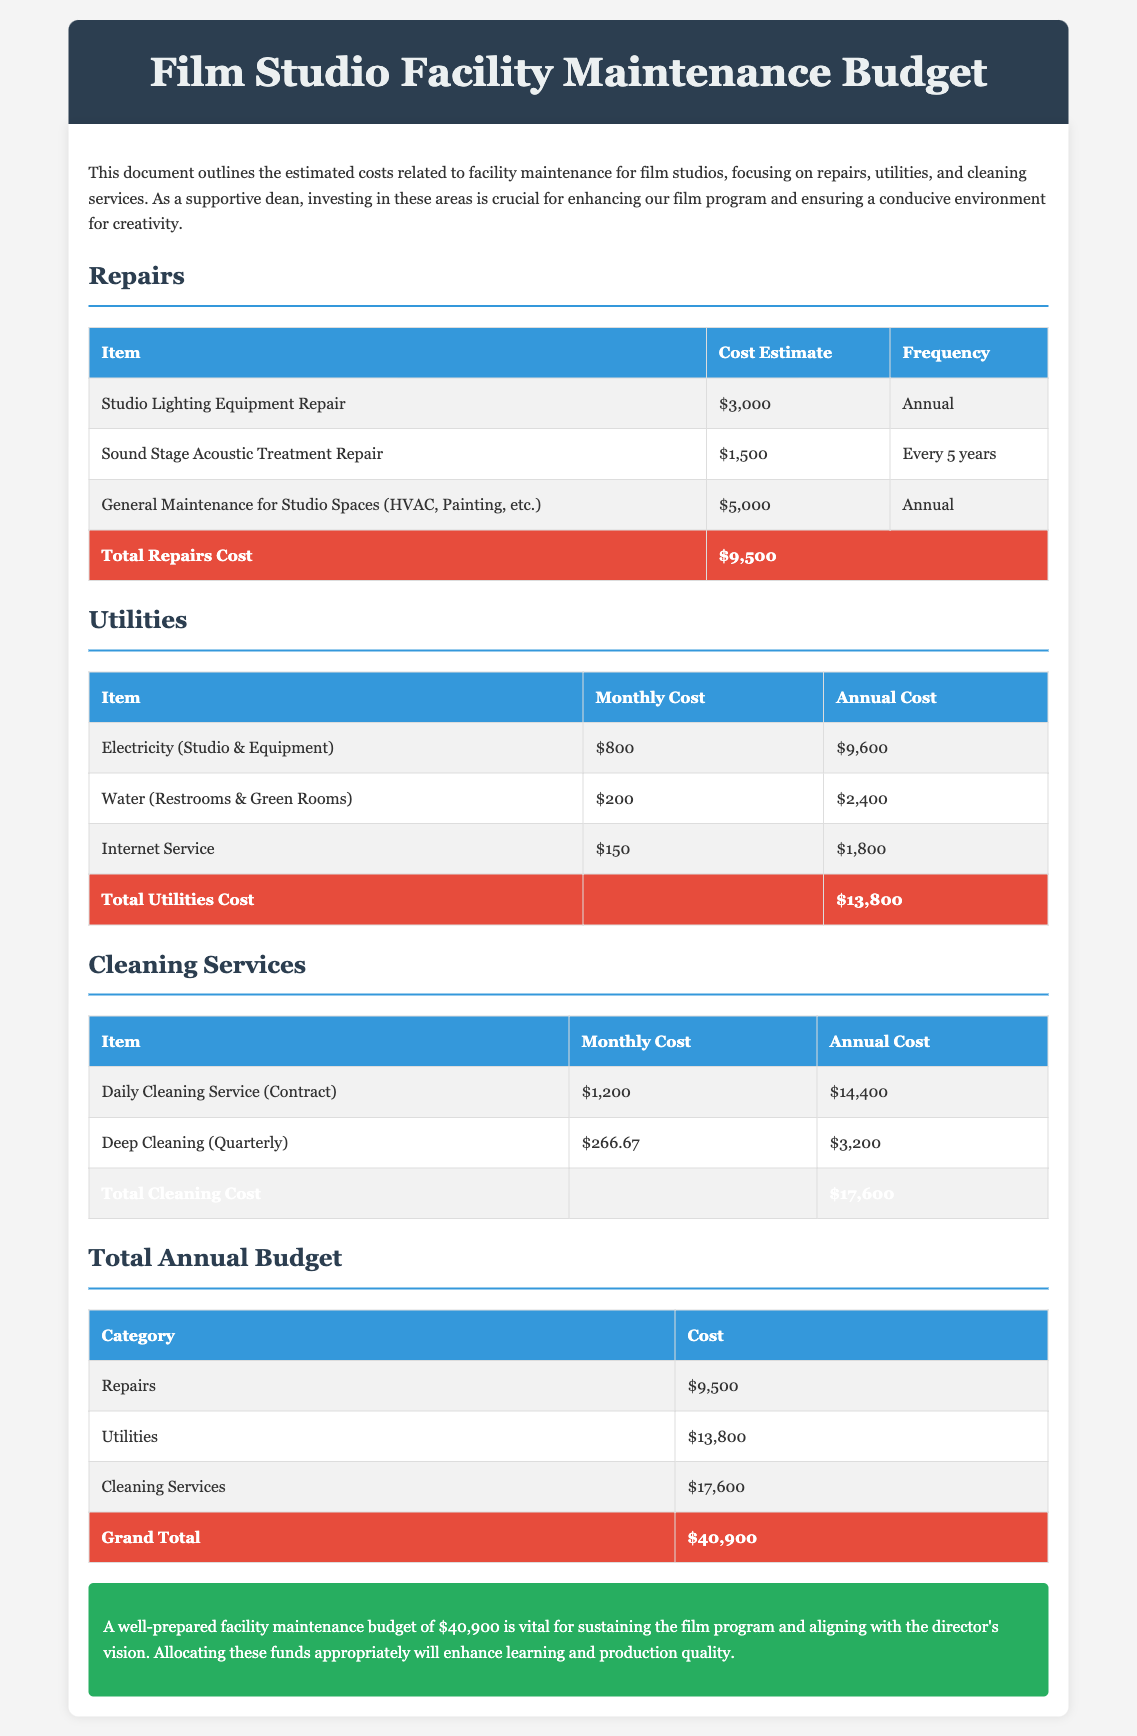what is the total cost for repairs? The total cost for repairs is the sum of all individual repair costs listed in the document.
Answer: $9,500 how much is the monthly cost for electricity? The monthly cost for electricity is specified in the utilities section of the document.
Answer: $800 how often is general maintenance for studio spaces conducted? The frequency of general maintenance is mentioned in the repairs section of the document.
Answer: Annual what is the total annual utilities cost? The total annual utilities cost is derived from all monthly costs summed up annually.
Answer: $13,800 how much does daily cleaning service cost annually? The annual cost for the daily cleaning service is found in the cleaning services section.
Answer: $14,400 what is the grand total of the budget? The grand total of the budget is calculated by summing all categories in the total annual budget section.
Answer: $40,900 how much is spent on deep cleaning quarterly? The cost for deep cleaning is specified and indicates the quarterly expenditure.
Answer: $3,200 what is the cost estimate for sound stage acoustic treatment repair? The specific cost estimate for sound stage acoustic treatment repair is listed under repairs.
Answer: $1,500 how often is deep cleaning performed? The frequency of deep cleaning is explicitly stated in the cleaning services section of the document.
Answer: Quarterly 